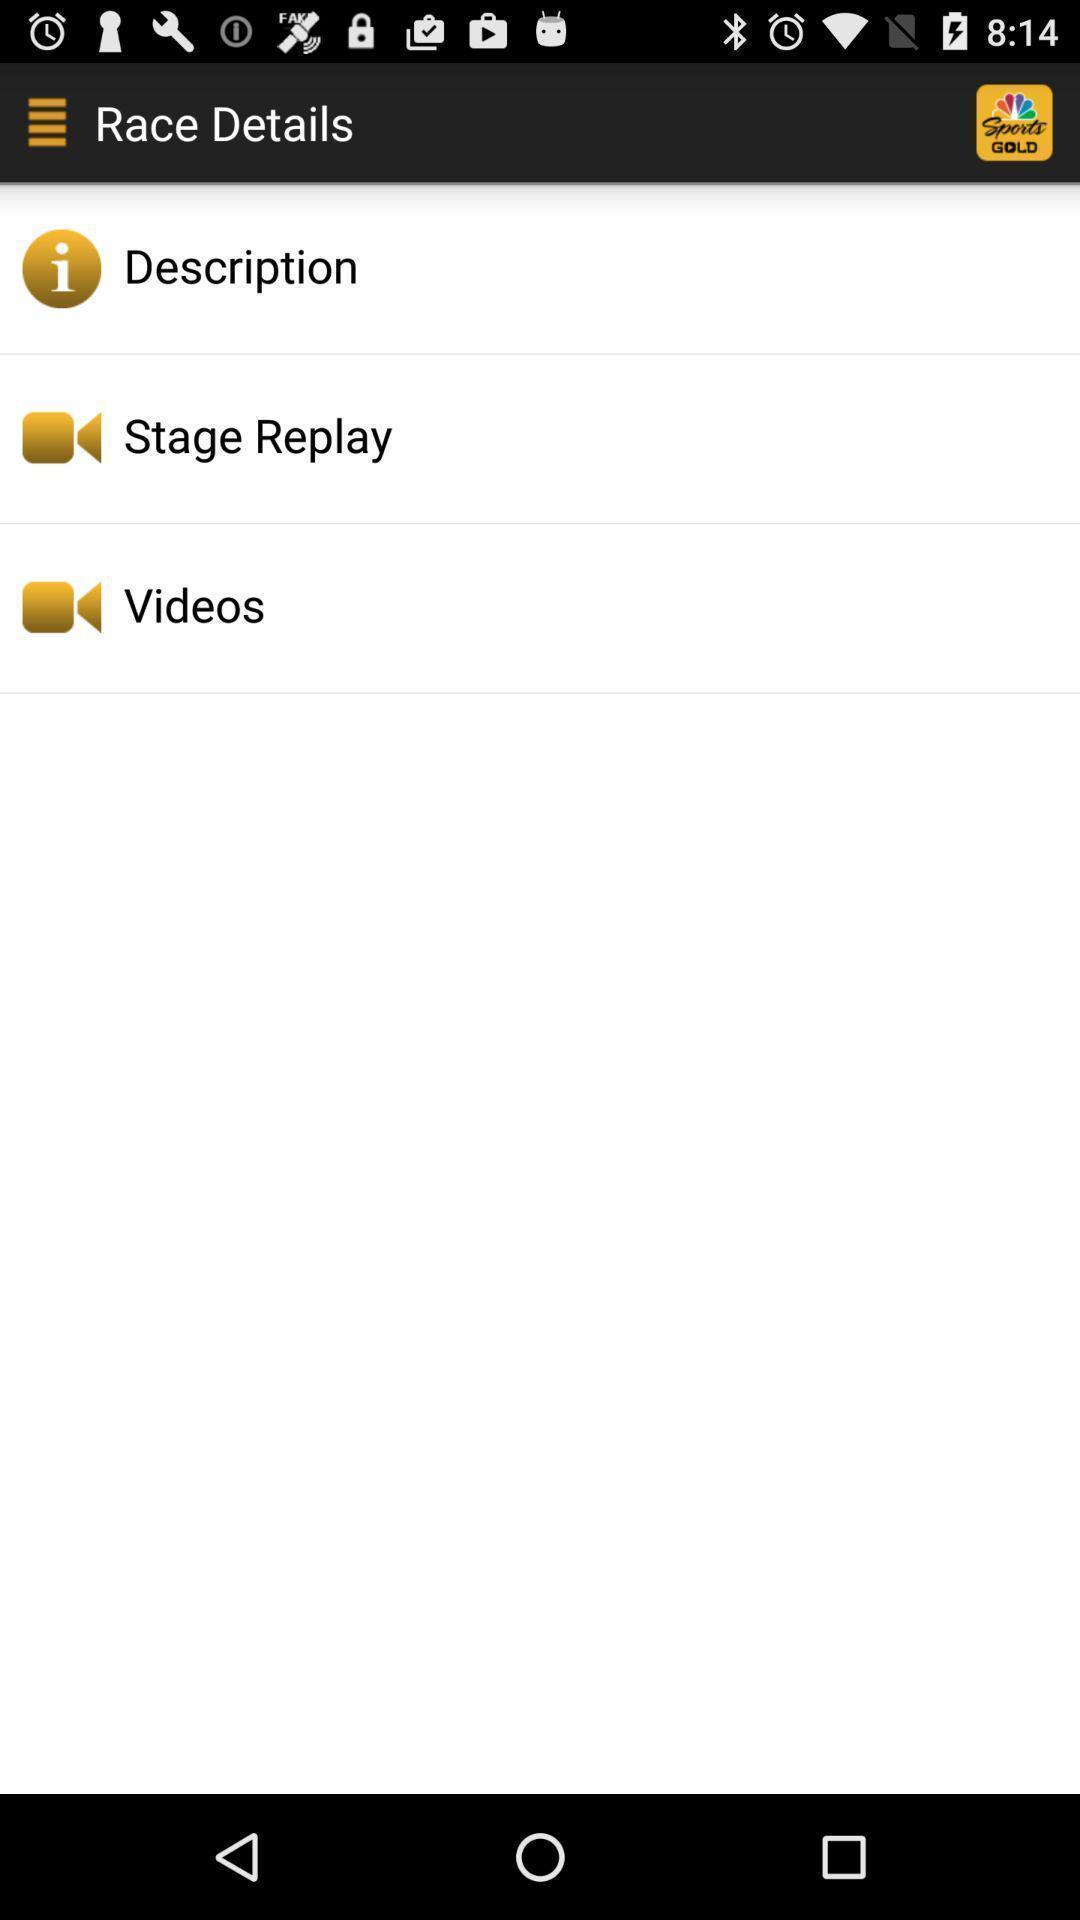Tell me what you see in this picture. Page showing details with options. 